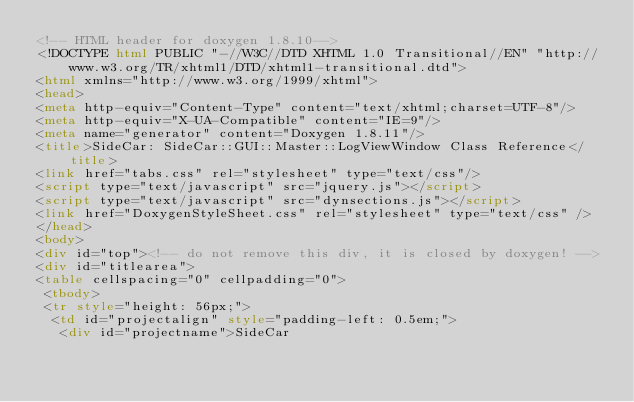<code> <loc_0><loc_0><loc_500><loc_500><_HTML_><!-- HTML header for doxygen 1.8.10-->
<!DOCTYPE html PUBLIC "-//W3C//DTD XHTML 1.0 Transitional//EN" "http://www.w3.org/TR/xhtml1/DTD/xhtml1-transitional.dtd">
<html xmlns="http://www.w3.org/1999/xhtml">
<head>
<meta http-equiv="Content-Type" content="text/xhtml;charset=UTF-8"/>
<meta http-equiv="X-UA-Compatible" content="IE=9"/>
<meta name="generator" content="Doxygen 1.8.11"/>
<title>SideCar: SideCar::GUI::Master::LogViewWindow Class Reference</title>
<link href="tabs.css" rel="stylesheet" type="text/css"/>
<script type="text/javascript" src="jquery.js"></script>
<script type="text/javascript" src="dynsections.js"></script>
<link href="DoxygenStyleSheet.css" rel="stylesheet" type="text/css" />
</head>
<body>
<div id="top"><!-- do not remove this div, it is closed by doxygen! -->
<div id="titlearea">
<table cellspacing="0" cellpadding="0">
 <tbody>
 <tr style="height: 56px;">
  <td id="projectalign" style="padding-left: 0.5em;">
   <div id="projectname">SideCar</code> 